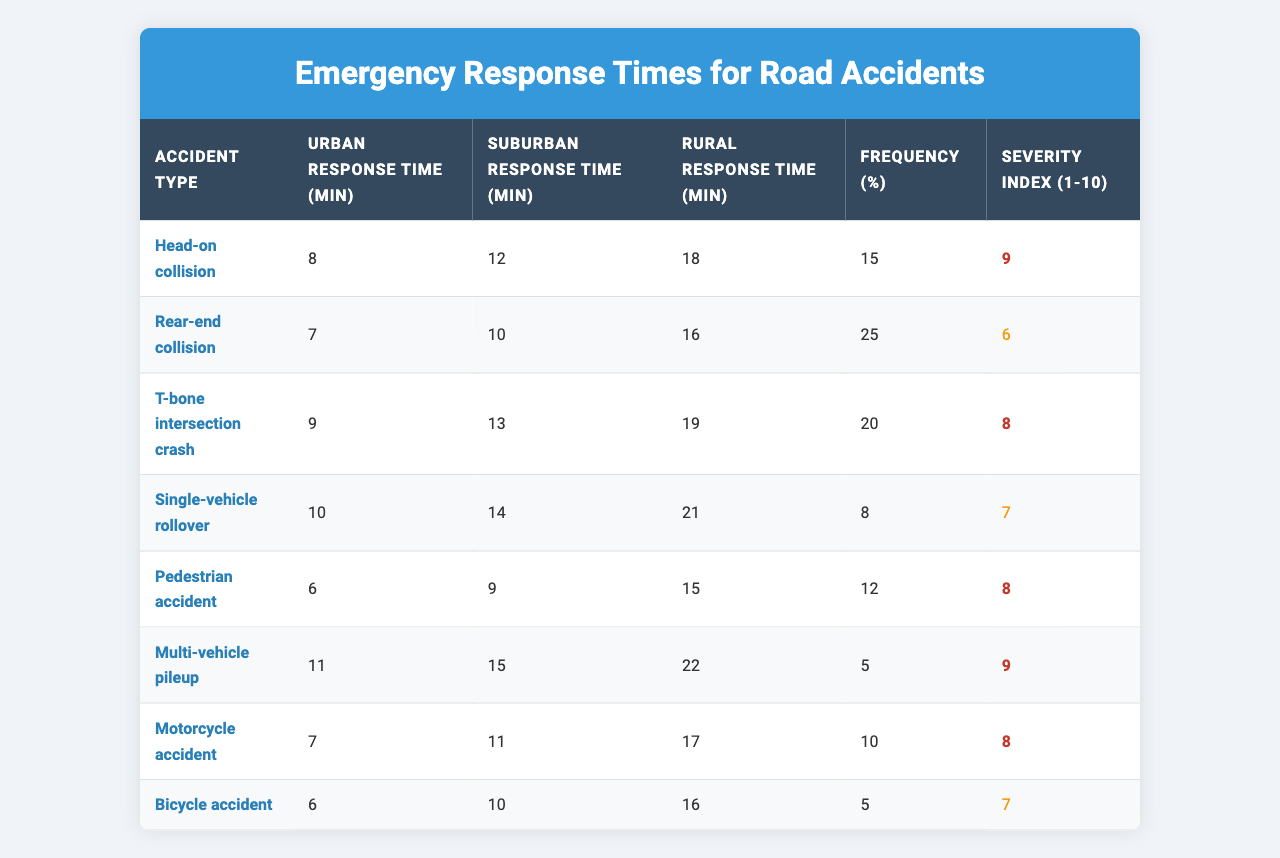What is the urban response time for a head-on collision? According to the table, the urban response time for a head-on collision is explicitly stated as 8 minutes.
Answer: 8 minutes Which type of accident has the longest rural response time? The table shows that the multi-vehicle pileup has the longest rural response time of 22 minutes.
Answer: Multi-vehicle pileup What is the frequency percentage of single-vehicle rollover accidents? The frequency percentage for single-vehicle rollover accidents is given in the table as 8%.
Answer: 8% Is the severity index for a bicycle accident greater than that for a motorcycle accident? The severity index for a bicycle accident is 7, while for a motorcycle accident, it is 8; therefore, the severity index for a bicycle accident is not greater.
Answer: No What is the average urban response time for all accident types? To calculate the average urban response time, sum the urban response times (8 + 7 + 9 + 10 + 6 + 11 + 7 + 6 = 68) and divide by the number of accident types (8): 68 / 8 = 8.5 minutes.
Answer: 8.5 minutes How many accident types have an urban response time of less than 8 minutes? According to the table, only the pedestrian accident and bicycle accident have urban response times of 6 minutes each, making a total of 2 accident types.
Answer: 2 What is the difference between the suburban response time of T-bone crashes and rear-end collisions? For T-bone intersection crashes, the suburban response time is 13 minutes, while for rear-end collisions, it is 10 minutes. The difference is 13 - 10 = 3 minutes.
Answer: 3 minutes Which accident type has the lowest severity index, and what is that index? The single-vehicle rollover has the lowest severity index of 7 in the table.
Answer: Single-vehicle rollover, 7 Do more frequent accidents (in terms of percentage) tend to have lower severity indices? The data shows that rear-end collisions have the highest frequency at 25% and a severity index of 6, while the multi-vehicle pileup, which is less frequent at 5%, has a severity index of 9. This indicates that higher frequency may not directly correlate with lower severity.
Answer: No What is the total percentage of frequency for accidents with severity indices of 8 or higher? The accidents with severity indices of 8 or higher are head-on collisions (15%), T-bone crashes (20%), multi-vehicle pileups (5%), and motorcycle accidents (10%). The total frequency percentage is 15 + 20 + 5 + 10 = 50%.
Answer: 50% 